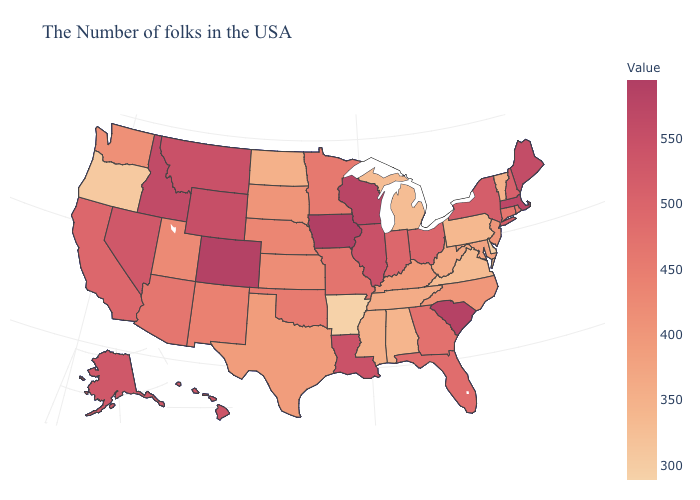Does Washington have a higher value than Tennessee?
Be succinct. Yes. Does Massachusetts have the highest value in the Northeast?
Concise answer only. Yes. Does Nebraska have a lower value than West Virginia?
Keep it brief. No. 